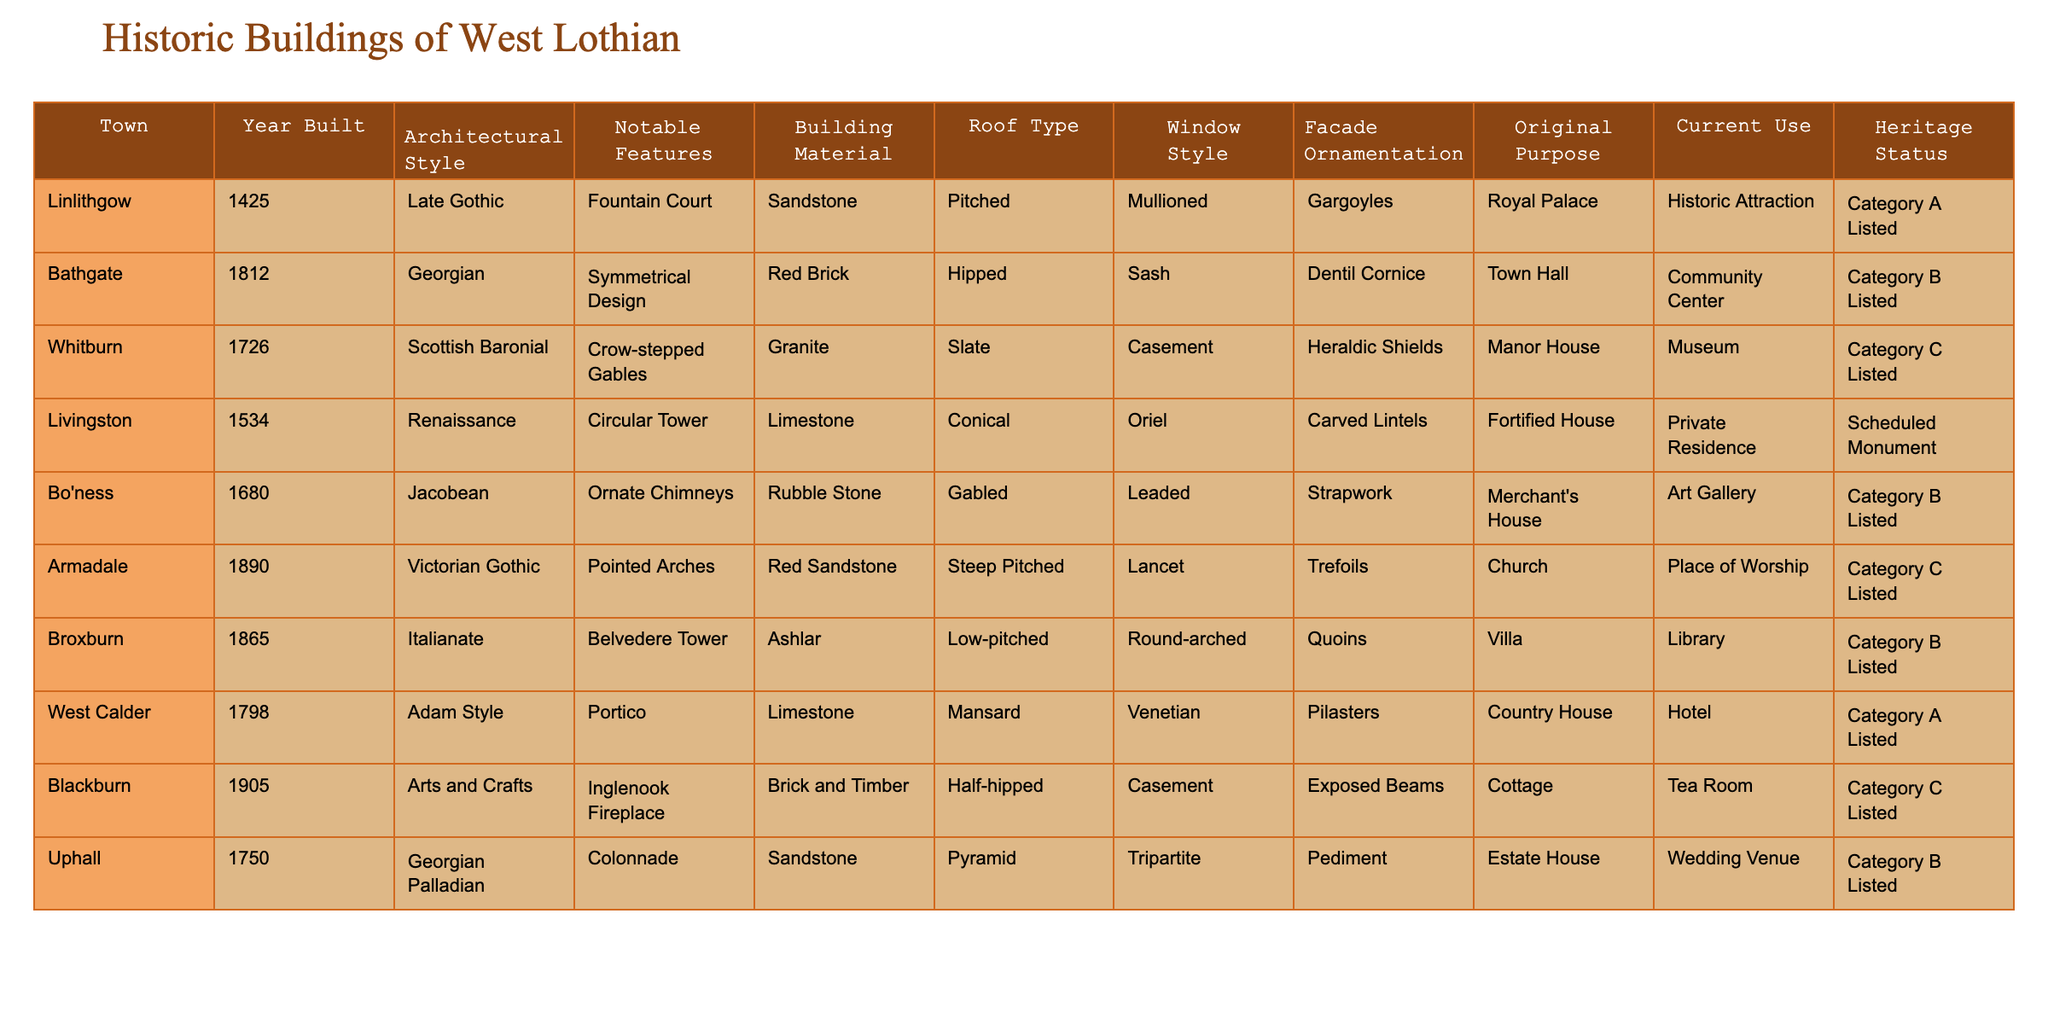What town has the oldest building in the table? The building in the table that was built first is in Linlithgow, constructed in 1425. This can be found by comparing the "Year Built" column.
Answer: Linlithgow How many buildings listed in the table are of Category A Heritage Status? There are two buildings with Category A status: the Royal Palace in Linlithgow and the Country House in West Calder. This is determined by counting the entries in the "Heritage Status" column that are labeled as Category A.
Answer: 2 What architectural style is associated with the building in Bathgate? The building in Bathgate, which was built in 1812, is styled as Georgian, as seen in the "Architectural Style" column corresponding to Bathgate.
Answer: Georgian Which town has a building originally used as a manor house? The town with a building originally used as a manor house is Whitburn, which was built in 1726. This is identified by looking at the "Original Purpose" column for each town.
Answer: Whitburn What is the primary building material used for the Victorian Gothic building in Armadale? The Victorian Gothic building in Armadale, built in 1890, uses red sandstone as its primary building material, as indicated in the "Building Material" column.
Answer: Red Sandstone If we compare the architectural styles, which town boasts an Italianate style? Broxburn is the town that features an Italianate architectural style for its building, built in 1865, as listed in the "Architectural Style" column.
Answer: Broxburn Which window style is found in the Renaissance building in Livingston? The window style of the Renaissance building in Livingston is Oriel, according to the corresponding entry in the "Window Style" column for that town.
Answer: Oriel How many buildings in the table were built in the 18th century? There are four buildings constructed in the 18th century: in Linlithgow (1425), Whitburn (1726), Uphall (1750), and West Calder (1798). This is found by listing the years that fall within the 1700s from the "Year Built" column.
Answer: 4 In terms of current use, which town's building is now a place of worship? The building in Armadale is the one currently used as a place of worship, as noted under the "Current Use" column.
Answer: Armadale Is there a building in the table with a crenellated roof type? No, there is no mention of any building having a crenellated roof type in the provided data. This information can be found by reviewing the "Roof Type" column.
Answer: No What notable feature is listed for the Arts and Crafts building in Blackburn? The notable feature of the Arts and Crafts building in Blackburn is the Inglenook Fireplace, as described in the "Notable Features" column corresponding to that town.
Answer: Inglenook Fireplace 